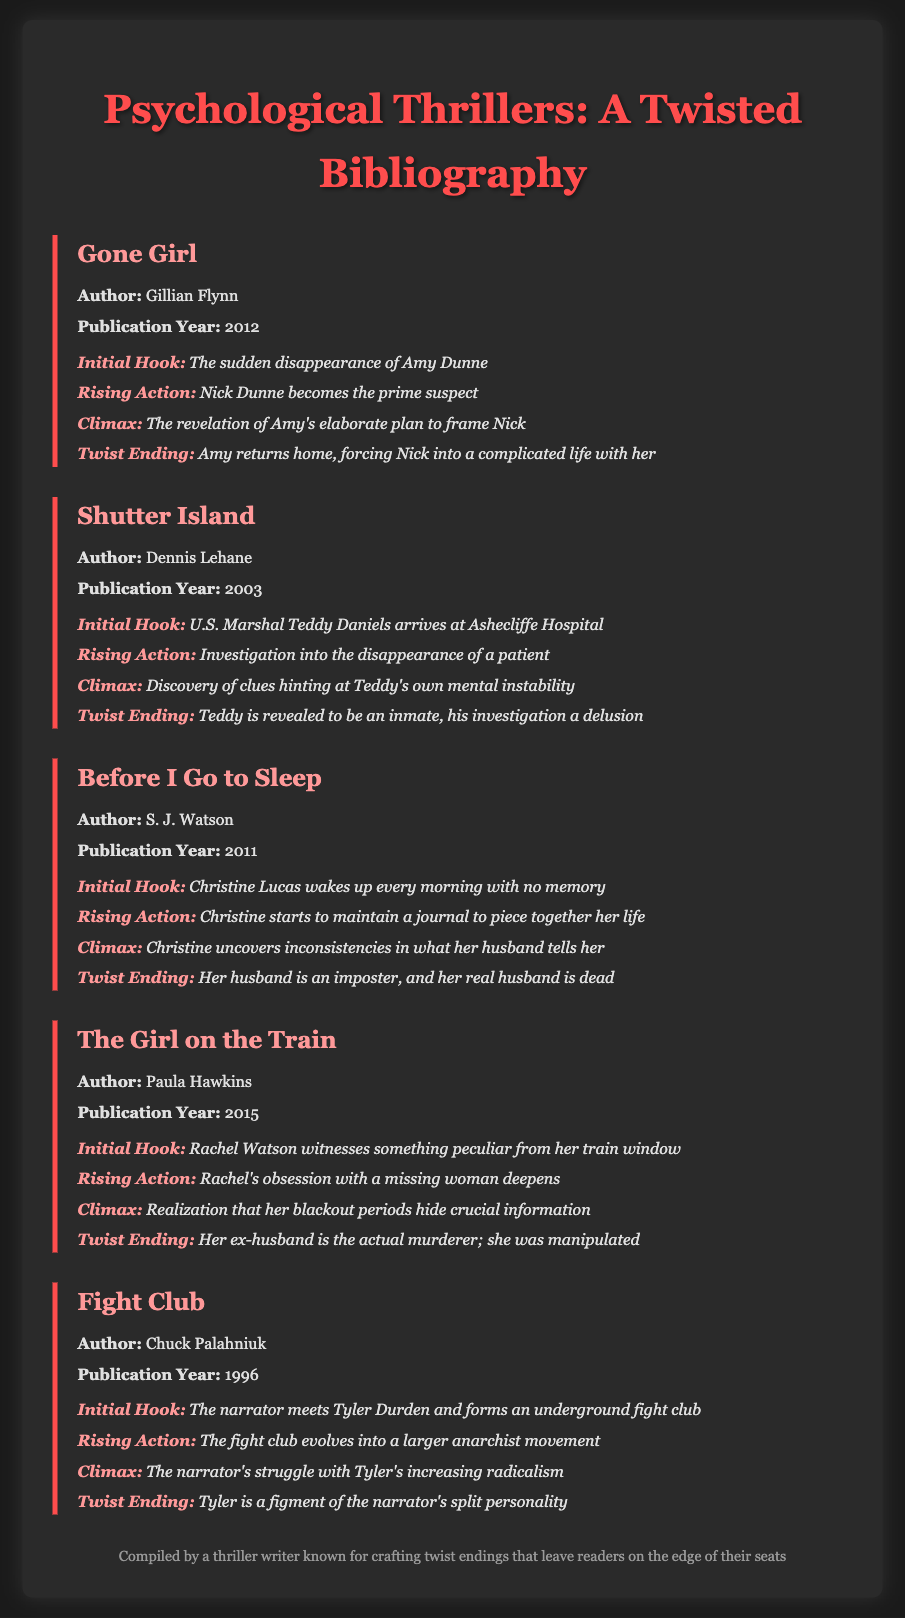What is the title of the first book listed? The first book listed in the bibliography is "Gone Girl."
Answer: Gone Girl Who is the author of "The Girl on the Train"? The author of "The Girl on the Train" is Paula Hawkins.
Answer: Paula Hawkins What year was "Fight Club" published? "Fight Club" was published in the year 1996.
Answer: 1996 What is the initial hook of "Before I Go to Sleep"? The initial hook is about Christine waking up every morning with no memory.
Answer: Christine Lucas wakes up every morning with no memory What is the twist ending of "Shutter Island"? The twist ending reveals that Teddy is actually an inmate, not a marshal.
Answer: Teddy is revealed to be an inmate What structure type is predominantly used in the document? The document primarily uses a bibliographic structure and organizes books by title, author, and plot structure.
Answer: Bibliography What is the climax of "Gone Girl"? The climax involves the revelation of Amy's elaborate plan to frame Nick.
Answer: The revelation of Amy's elaborate plan to frame Nick Which book features a character that is a figment of the narrator's imagination? "Fight Club" features Tyler Durden as a figment of the narrator's split personality.
Answer: Fight Club What comes after the rising action in the plot structure? The structure presented consists of a climax that follows the rising action.
Answer: Climax 